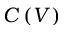<formula> <loc_0><loc_0><loc_500><loc_500>C \left ( V \right )</formula> 